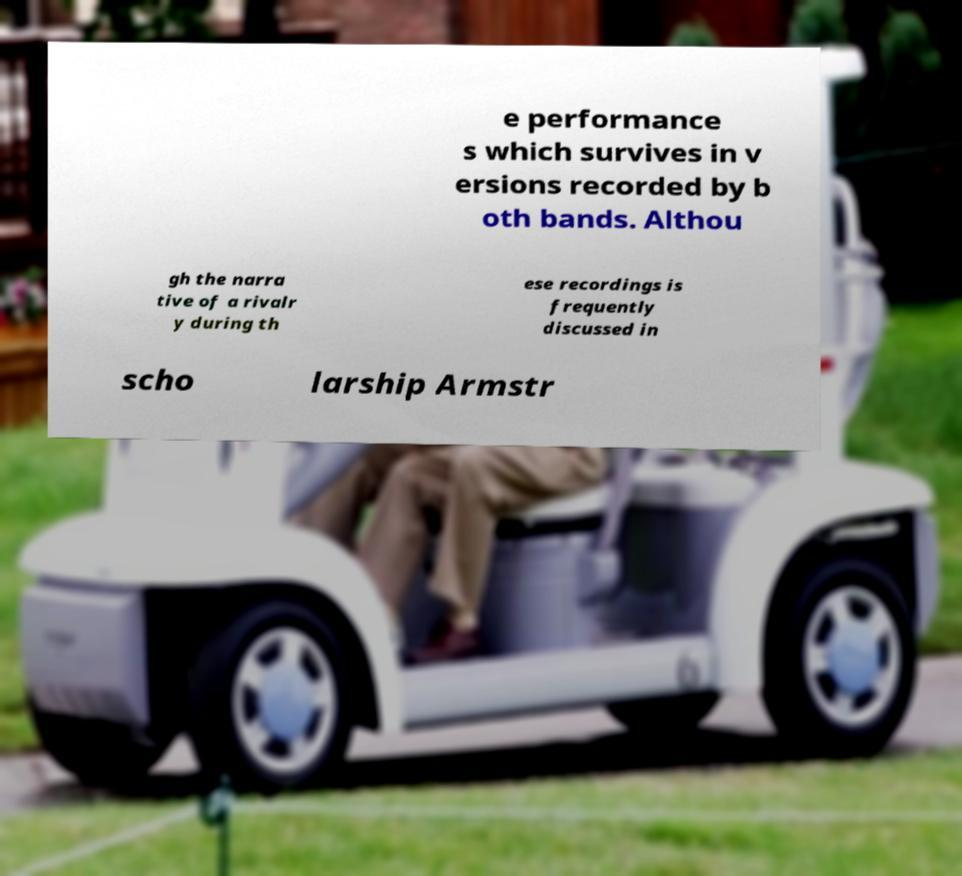Can you accurately transcribe the text from the provided image for me? e performance s which survives in v ersions recorded by b oth bands. Althou gh the narra tive of a rivalr y during th ese recordings is frequently discussed in scho larship Armstr 